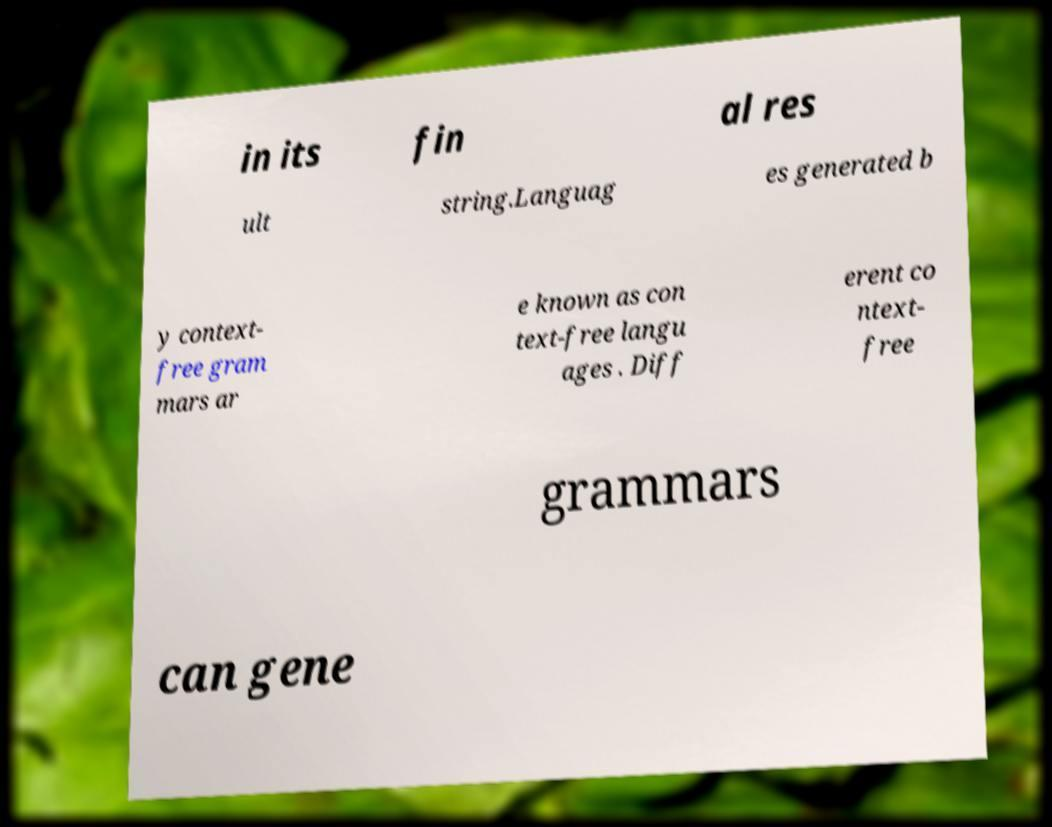Can you accurately transcribe the text from the provided image for me? in its fin al res ult string.Languag es generated b y context- free gram mars ar e known as con text-free langu ages . Diff erent co ntext- free grammars can gene 